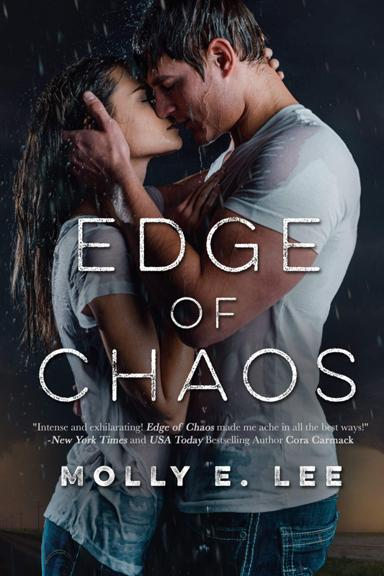What is the title of the book mentioned in the image? The title of the book shown in the image is 'Edge of Chaos,' authored by Molly E. Lee. This novel appears to be a thrilling romance based on its evocative cover portraying a couple in a rain-soaked embrace. 